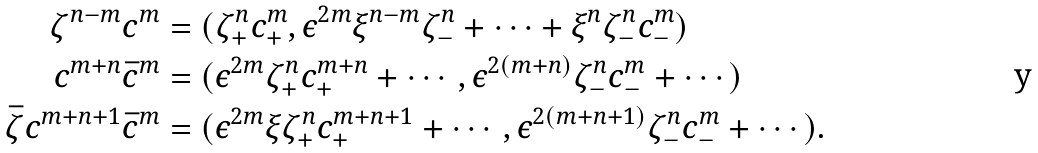<formula> <loc_0><loc_0><loc_500><loc_500>\zeta ^ { n - m } c ^ { m } & = ( \zeta _ { + } ^ { n } c _ { + } ^ { m } , \epsilon ^ { 2 m } \xi ^ { n - m } \zeta _ { - } ^ { n } + \cdots + \xi ^ { n } \zeta _ { - } ^ { n } c _ { - } ^ { m } ) \\ c ^ { m + n } \bar { c } ^ { m } & = ( \epsilon ^ { 2 m } \zeta _ { + } ^ { n } c _ { + } ^ { m + n } + \cdots , \epsilon ^ { 2 ( m + n ) } \zeta _ { - } ^ { n } c _ { - } ^ { m } + \cdots ) \\ \bar { \zeta } c ^ { m + n + 1 } \bar { c } ^ { m } & = ( \epsilon ^ { 2 m } \xi \zeta _ { + } ^ { n } c _ { + } ^ { m + n + 1 } + \cdots , \epsilon ^ { 2 ( m + n + 1 ) } \zeta _ { - } ^ { n } c _ { - } ^ { m } + \cdots ) .</formula> 